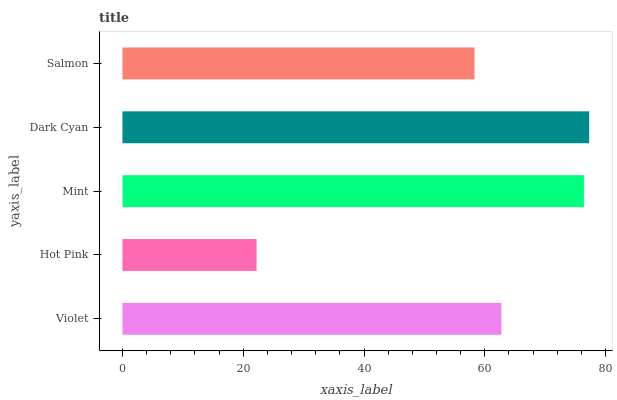Is Hot Pink the minimum?
Answer yes or no. Yes. Is Dark Cyan the maximum?
Answer yes or no. Yes. Is Mint the minimum?
Answer yes or no. No. Is Mint the maximum?
Answer yes or no. No. Is Mint greater than Hot Pink?
Answer yes or no. Yes. Is Hot Pink less than Mint?
Answer yes or no. Yes. Is Hot Pink greater than Mint?
Answer yes or no. No. Is Mint less than Hot Pink?
Answer yes or no. No. Is Violet the high median?
Answer yes or no. Yes. Is Violet the low median?
Answer yes or no. Yes. Is Hot Pink the high median?
Answer yes or no. No. Is Hot Pink the low median?
Answer yes or no. No. 